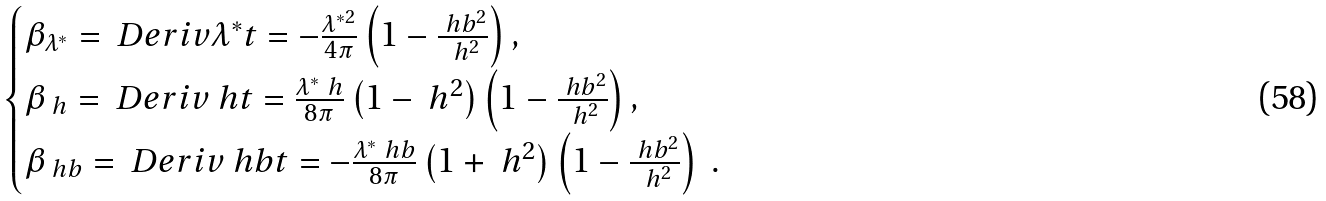Convert formula to latex. <formula><loc_0><loc_0><loc_500><loc_500>\begin{cases} \beta _ { \lambda ^ { \ast } } = \ D e r i v { \lambda ^ { \ast } } { t } = - \frac { \lambda ^ { \ast 2 } } { 4 \pi } \left ( 1 - \frac { \ h b ^ { 2 } } { \ h ^ { 2 } } \right ) , \\ \beta _ { \ h } = \ D e r i v { \ h } { t } = \frac { \lambda ^ { \ast } \ h } { 8 \pi } \left ( 1 - \ h ^ { 2 } \right ) \left ( 1 - \frac { \ h b ^ { 2 } } { \ h ^ { 2 } } \right ) , \\ \beta _ { \ h b } = \ D e r i v { \ h b } { t } = - \frac { \lambda ^ { \ast } \ h b } { 8 \pi } \left ( 1 + \ h ^ { 2 } \right ) \left ( 1 - \frac { \ h b ^ { 2 } } { \ h ^ { 2 } } \right ) \ . \end{cases}</formula> 